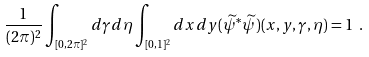<formula> <loc_0><loc_0><loc_500><loc_500>\frac { 1 } { ( 2 \pi ) ^ { 2 } } \int _ { [ 0 , 2 \pi ] ^ { 2 } } d \gamma d \eta \int _ { [ 0 , 1 ] ^ { 2 } } d x d y ( \widetilde { \psi } ^ { \ast } \widetilde { \psi } ) ( x , y , \gamma , \eta ) = 1 \ .</formula> 